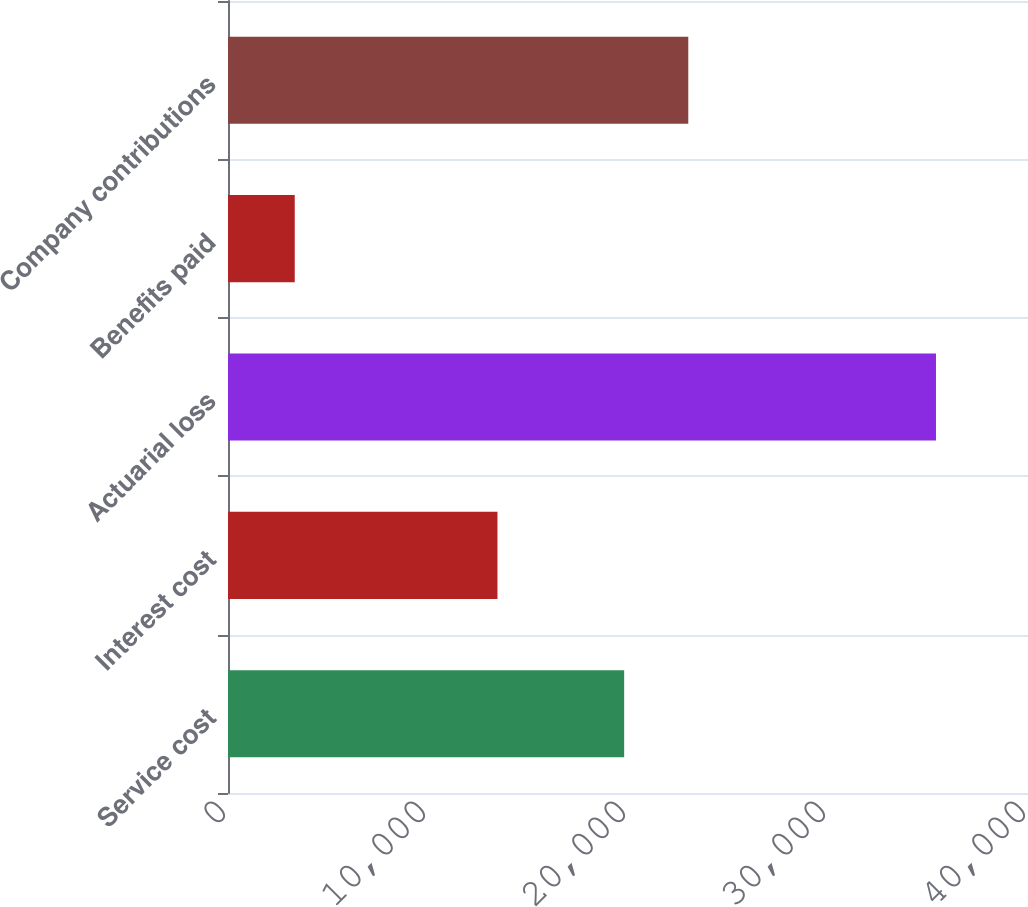<chart> <loc_0><loc_0><loc_500><loc_500><bar_chart><fcel>Service cost<fcel>Interest cost<fcel>Actuarial loss<fcel>Benefits paid<fcel>Company contributions<nl><fcel>19808<fcel>13473<fcel>35399<fcel>3337<fcel>23014.2<nl></chart> 